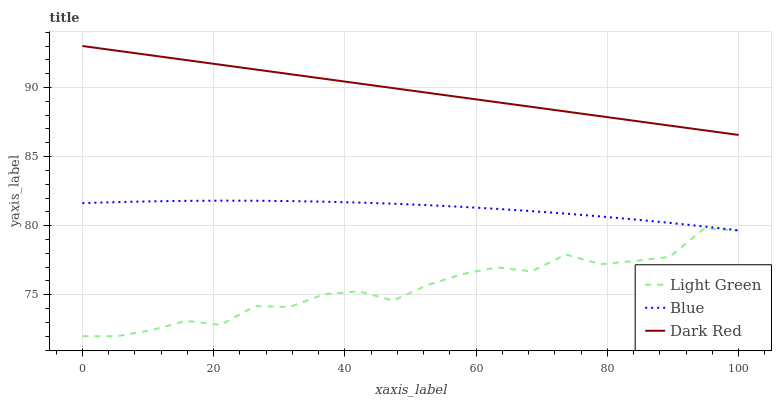Does Light Green have the minimum area under the curve?
Answer yes or no. Yes. Does Dark Red have the maximum area under the curve?
Answer yes or no. Yes. Does Dark Red have the minimum area under the curve?
Answer yes or no. No. Does Light Green have the maximum area under the curve?
Answer yes or no. No. Is Dark Red the smoothest?
Answer yes or no. Yes. Is Light Green the roughest?
Answer yes or no. Yes. Is Light Green the smoothest?
Answer yes or no. No. Is Dark Red the roughest?
Answer yes or no. No. Does Light Green have the lowest value?
Answer yes or no. Yes. Does Dark Red have the lowest value?
Answer yes or no. No. Does Dark Red have the highest value?
Answer yes or no. Yes. Does Light Green have the highest value?
Answer yes or no. No. Is Blue less than Dark Red?
Answer yes or no. Yes. Is Dark Red greater than Blue?
Answer yes or no. Yes. Does Blue intersect Dark Red?
Answer yes or no. No. 